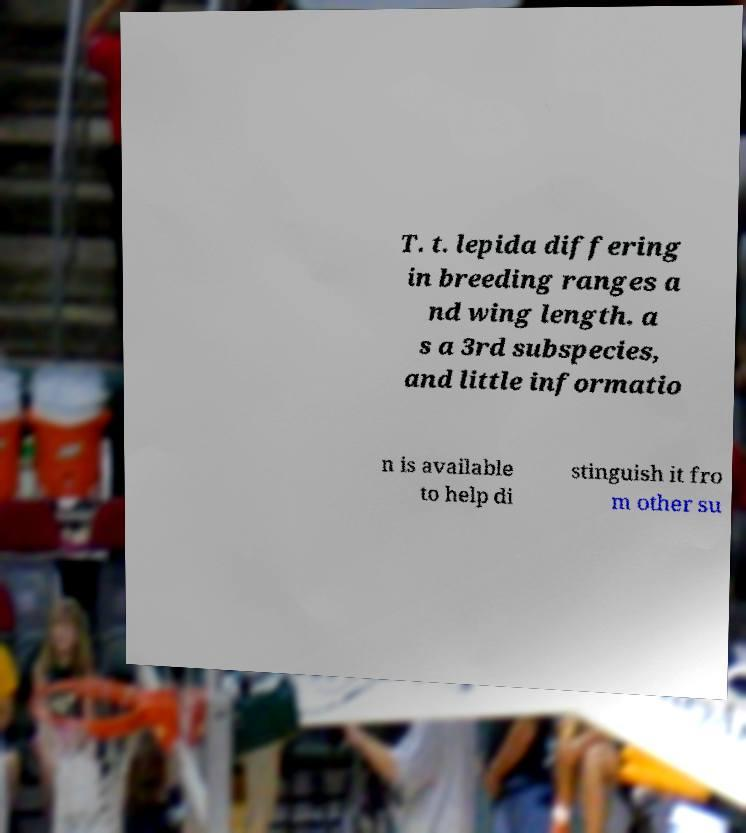For documentation purposes, I need the text within this image transcribed. Could you provide that? T. t. lepida differing in breeding ranges a nd wing length. a s a 3rd subspecies, and little informatio n is available to help di stinguish it fro m other su 